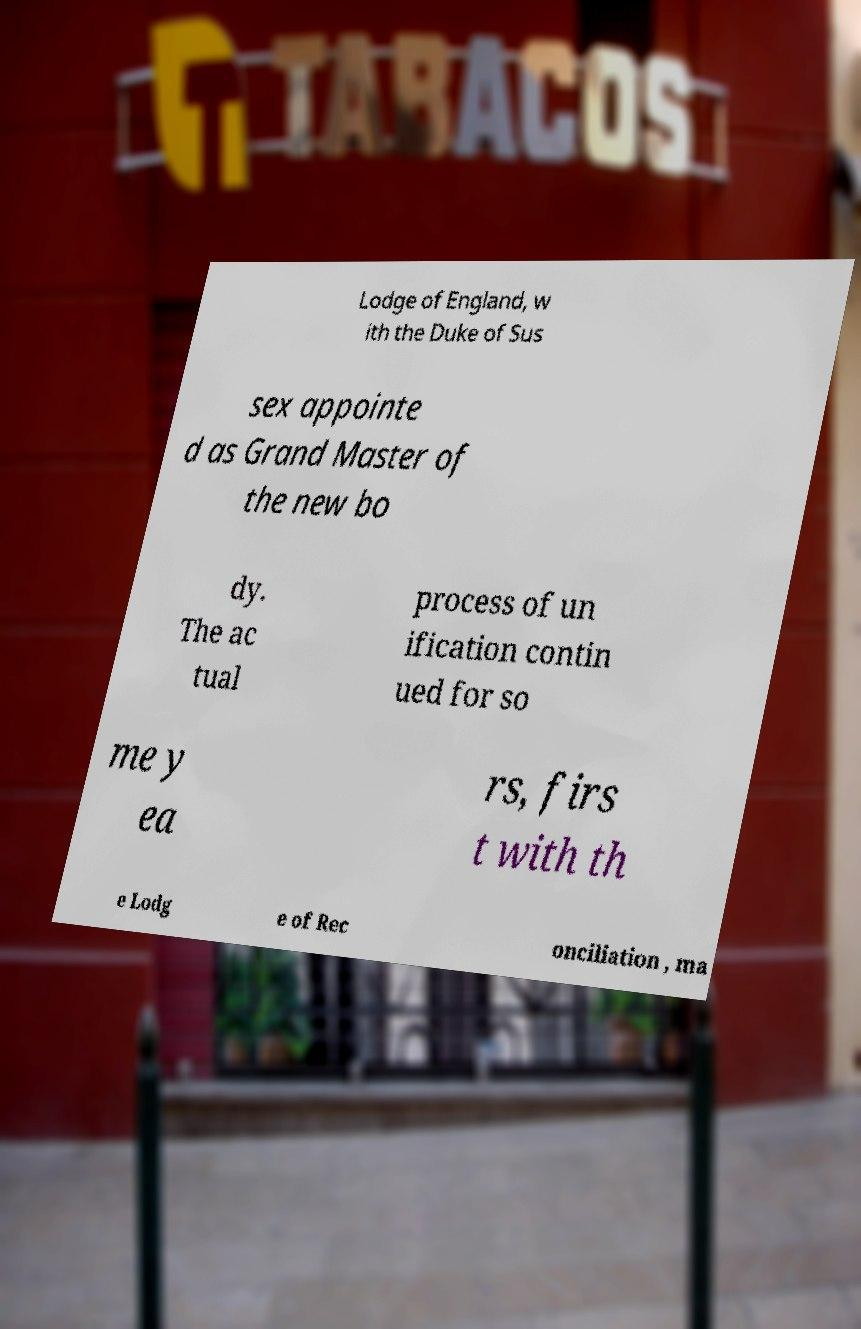What messages or text are displayed in this image? I need them in a readable, typed format. Lodge of England, w ith the Duke of Sus sex appointe d as Grand Master of the new bo dy. The ac tual process of un ification contin ued for so me y ea rs, firs t with th e Lodg e of Rec onciliation , ma 